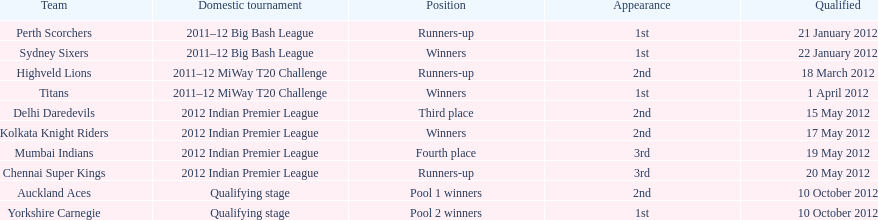Which teams were the last to qualify? Auckland Aces, Yorkshire Carnegie. 